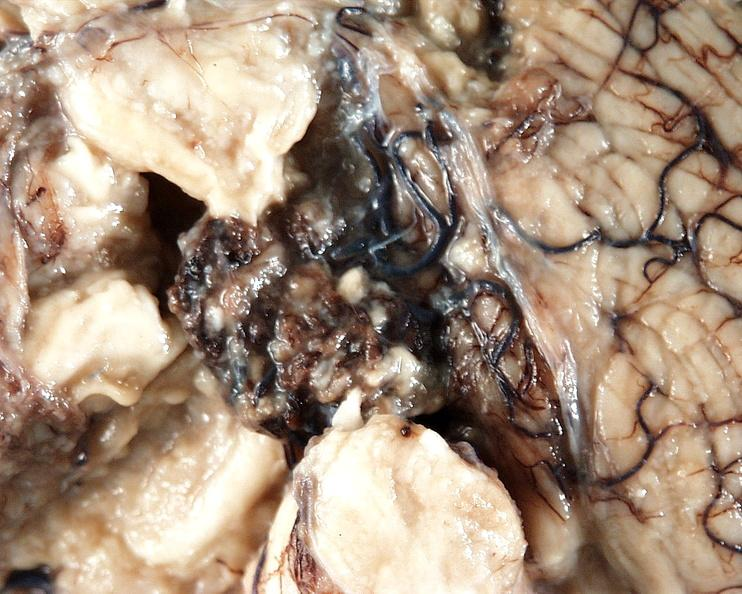does this protocol show brain, cryptococcal meningitis?
Answer the question using a single word or phrase. No 